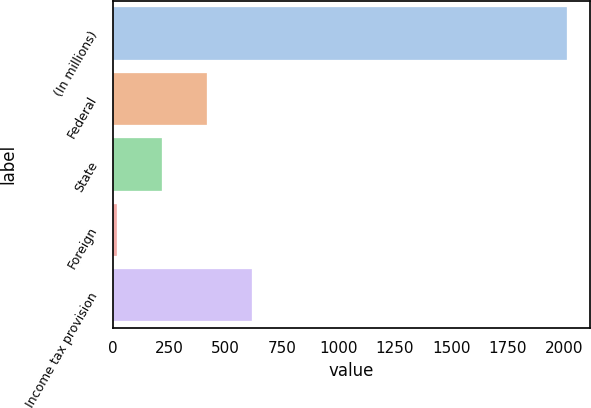Convert chart. <chart><loc_0><loc_0><loc_500><loc_500><bar_chart><fcel>(In millions)<fcel>Federal<fcel>State<fcel>Foreign<fcel>Income tax provision<nl><fcel>2016<fcel>416<fcel>216<fcel>16<fcel>616<nl></chart> 